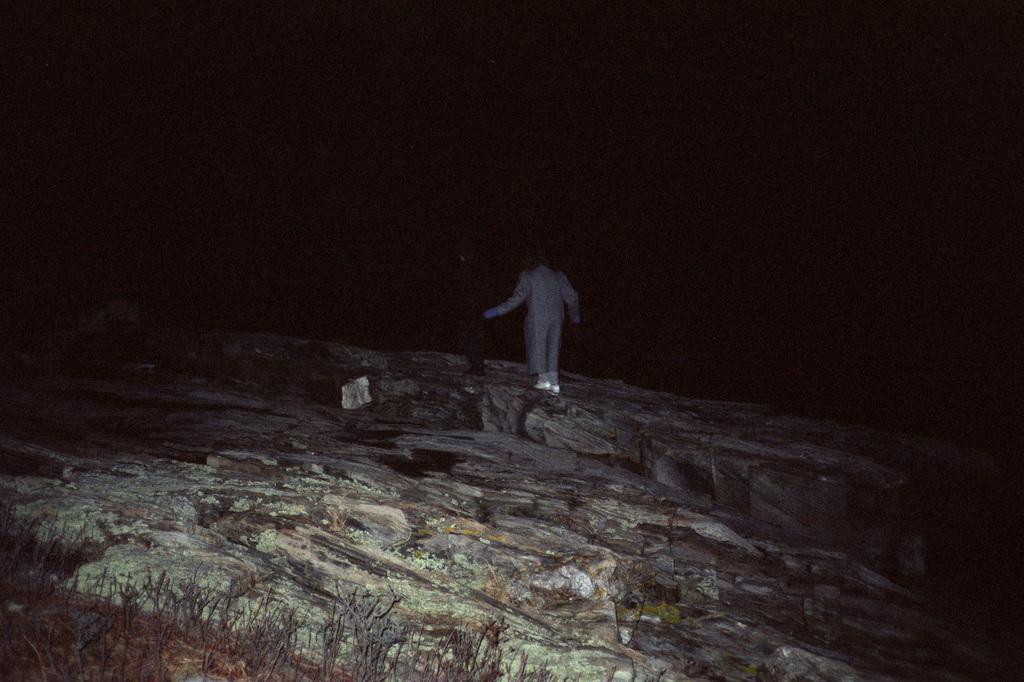Please provide a concise description of this image. This picture is taken during night, a person stand on rock in the middle, at the top I can see darkness. 